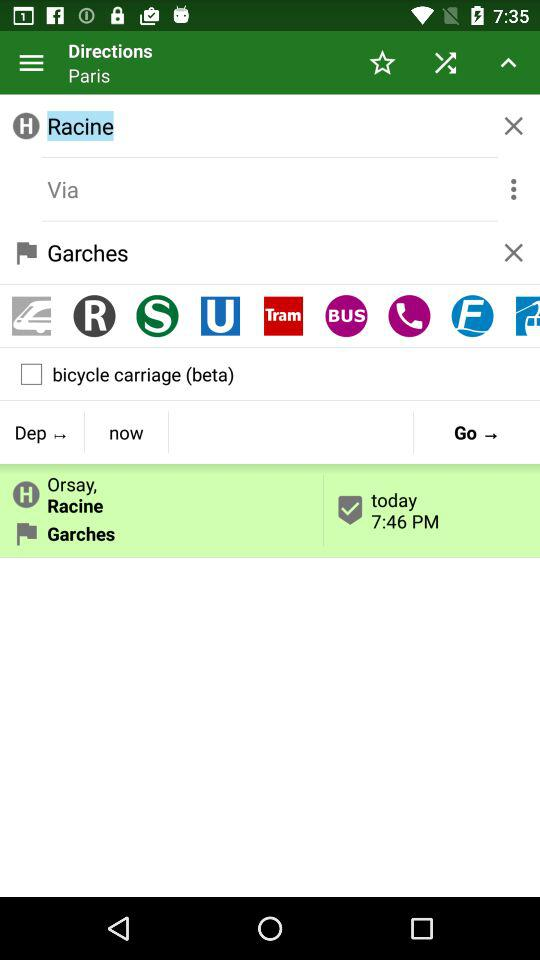What is the status of bicycle carriage? The status is "off". 